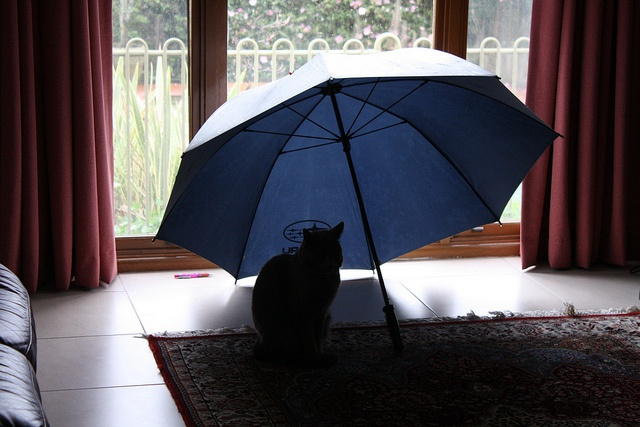Describe the objects in this image and their specific colors. I can see umbrella in black, navy, white, and darkblue tones, cat in black, navy, darkblue, and white tones, and couch in black, darkgray, and gray tones in this image. 